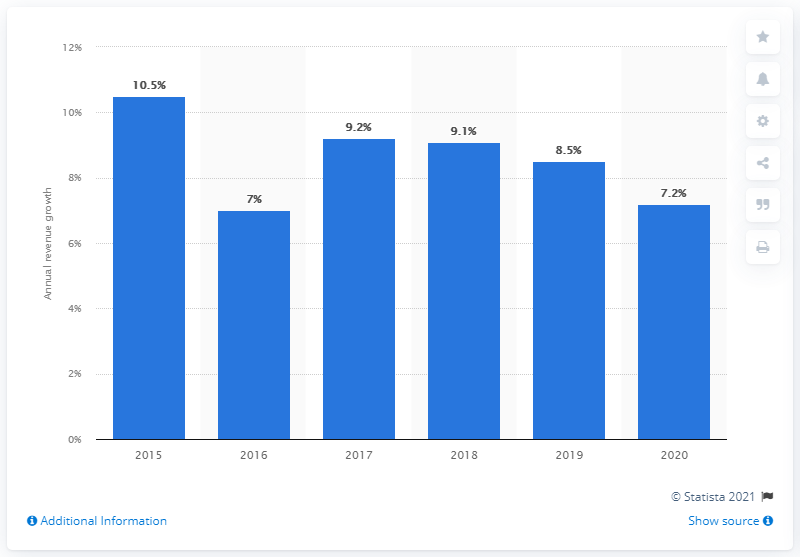Specify some key components in this picture. According to data from 2020, the average annual revenue growth of software companies was 7.2%. 